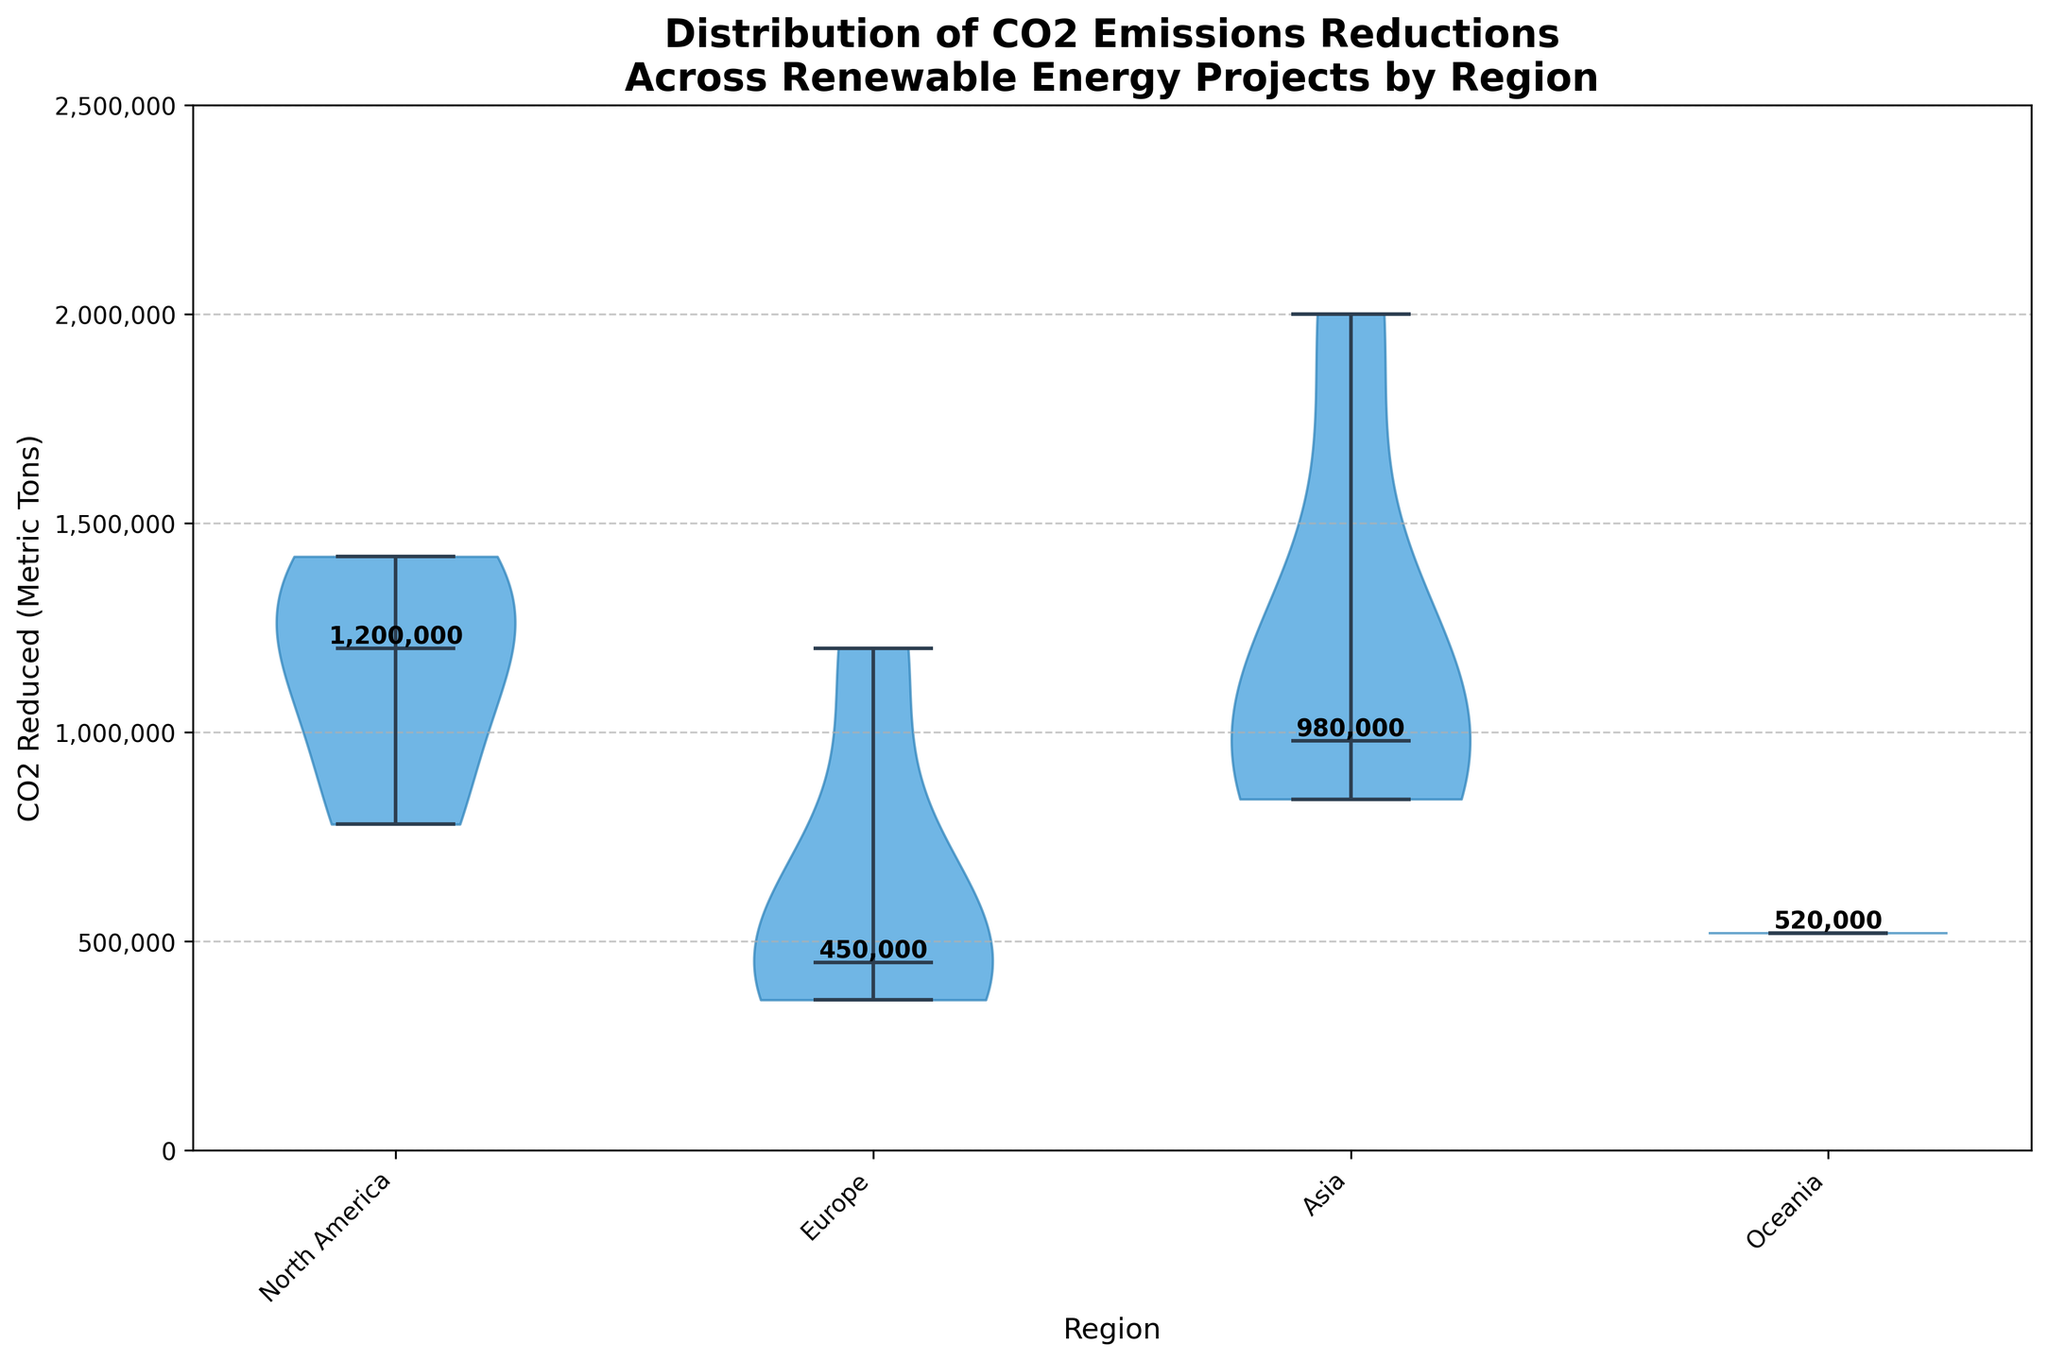What is the title of the figure? The title of the figure is usually at the top of the chart, it reads "Distribution of CO2 Emissions Reductions Across Renewable Energy Projects by Region".
Answer: Distribution of CO2 Emissions Reductions Across Renewable Energy Projects by Region Which region has the highest median value of CO2 emissions reductions? In the figure, the median values are marked by a horizontal line in the center of each violin plot. The highest median is in the Asia region.
Answer: Asia What is the median value of CO2 emissions reductions for North America? To find the median value, look for the horizontal line in the center of the North America violin plot. The annotation next to it indicates the median value is 1,100,000 metric tons.
Answer: 1,100,000 metric tons How does the spread (range) of CO2 emissions reductions differ between Europe and Asia? The spread is the vertical span of the violin plots. Europe's spread is from around 360,000 to 1,200,000 metric tons, whereas Asia's spread is from around 200,000 to 2,000,000 metric tons. Therefore, Asia has a larger spread.
Answer: Asia has a larger spread Which region has the smallest range of CO2 emissions reductions? Comparing the vertical spans of all the violin plots, Oceania has the smallest range, from around 520,000 to 520,000 metric tons.
Answer: Oceania What is the approximate CO2 reduction for the upper quartile in Europe? The upper quartile typically corresponds to the upper end of the thicker portion of the violin plot. In the Europe violin plot, this appears to be around 1,200,000 metric tons.
Answer: 1,200,000 metric tons How does the median value of CO2 emissions reductions in North America compare to Europe? The median values, marked by a horizontal line in each violin plot, show that North America's (1,100,000 metric tons) is higher than Europe's (450,000 metric tons).
Answer: North America is higher What can you infer about the CO2 emissions reductions distribution for Oceania? The violin plot for Oceania is a single thin line, indicating there is only one project with a CO2 reduction around 520,000 metric tons, with no variability.
Answer: Single value, 520,000 metric tons What is the range of CO2 emissions reductions for projects in Asia? The range is the difference between the maximum and minimum points of the violin plot for Asia, which spans from approximately 200,000 to 2,000,000 metric tons.
Answer: 200,000 to 2,000,000 metric tons 